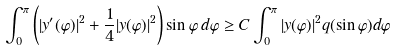Convert formula to latex. <formula><loc_0><loc_0><loc_500><loc_500>\int _ { 0 } ^ { \pi } \left ( | y ^ { \prime } ( \varphi ) | ^ { 2 } + \frac { 1 } { 4 } | y ( \varphi ) | ^ { 2 } \right ) \sin \varphi \, d \varphi \geq C \int _ { 0 } ^ { \pi } | y ( \varphi ) | ^ { 2 } q ( \sin \varphi ) d \varphi</formula> 